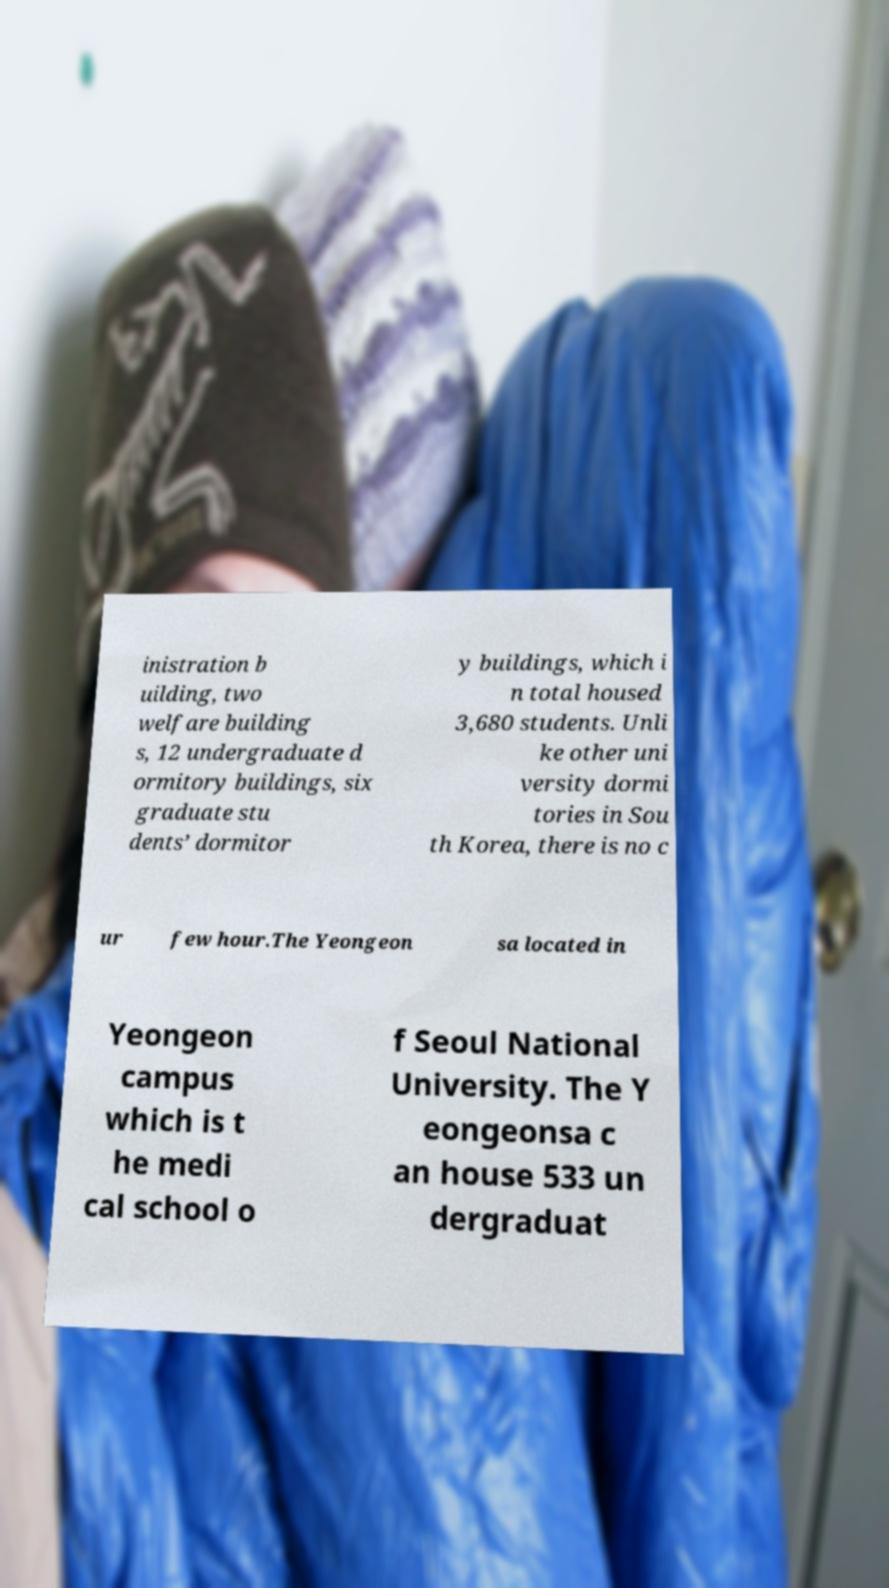For documentation purposes, I need the text within this image transcribed. Could you provide that? inistration b uilding, two welfare building s, 12 undergraduate d ormitory buildings, six graduate stu dents’ dormitor y buildings, which i n total housed 3,680 students. Unli ke other uni versity dormi tories in Sou th Korea, there is no c ur few hour.The Yeongeon sa located in Yeongeon campus which is t he medi cal school o f Seoul National University. The Y eongeonsa c an house 533 un dergraduat 